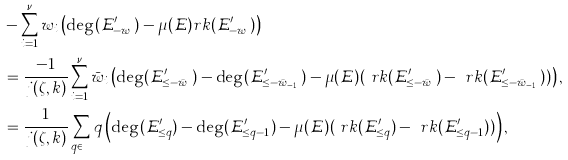Convert formula to latex. <formula><loc_0><loc_0><loc_500><loc_500>& - \sum _ { i = 1 } ^ { \nu } w _ { i } \left ( \deg ( \mathcal { E } ^ { \prime } _ { - w _ { i } } ) - \mu ( \mathcal { E } ) r k ( \mathcal { E } ^ { \prime } _ { - w _ { i } } ) \right ) \\ & = \frac { - 1 } { j ( \zeta , k ) } \sum _ { i = 1 } ^ { \nu } \bar { w } _ { i } \left ( \deg ( \mathcal { E } ^ { \prime } _ { \leq - \bar { w } _ { i } } ) - \deg ( \mathcal { E } ^ { \prime } _ { \leq - \bar { w } _ { i - 1 } } ) - \mu ( \mathcal { E } ) ( \ r k ( \mathcal { E } ^ { \prime } _ { \leq - \bar { w } _ { i } } ) - \ r k ( \mathcal { E } ^ { \prime } _ { \leq - \bar { w } _ { i - 1 } } ) ) \right ) , \\ & = \frac { 1 } { j ( \zeta , k ) } \sum _ { q \in \mathbb { Z } } q \left ( \deg ( \mathcal { E } ^ { \prime } _ { \leq q } ) - \deg ( \mathcal { E } ^ { \prime } _ { \leq q - 1 } ) - \mu ( \mathcal { E } ) ( \ r k ( \mathcal { E } ^ { \prime } _ { \leq q } ) - \ r k ( \mathcal { E } ^ { \prime } _ { \leq q - 1 } ) ) \right ) ,</formula> 